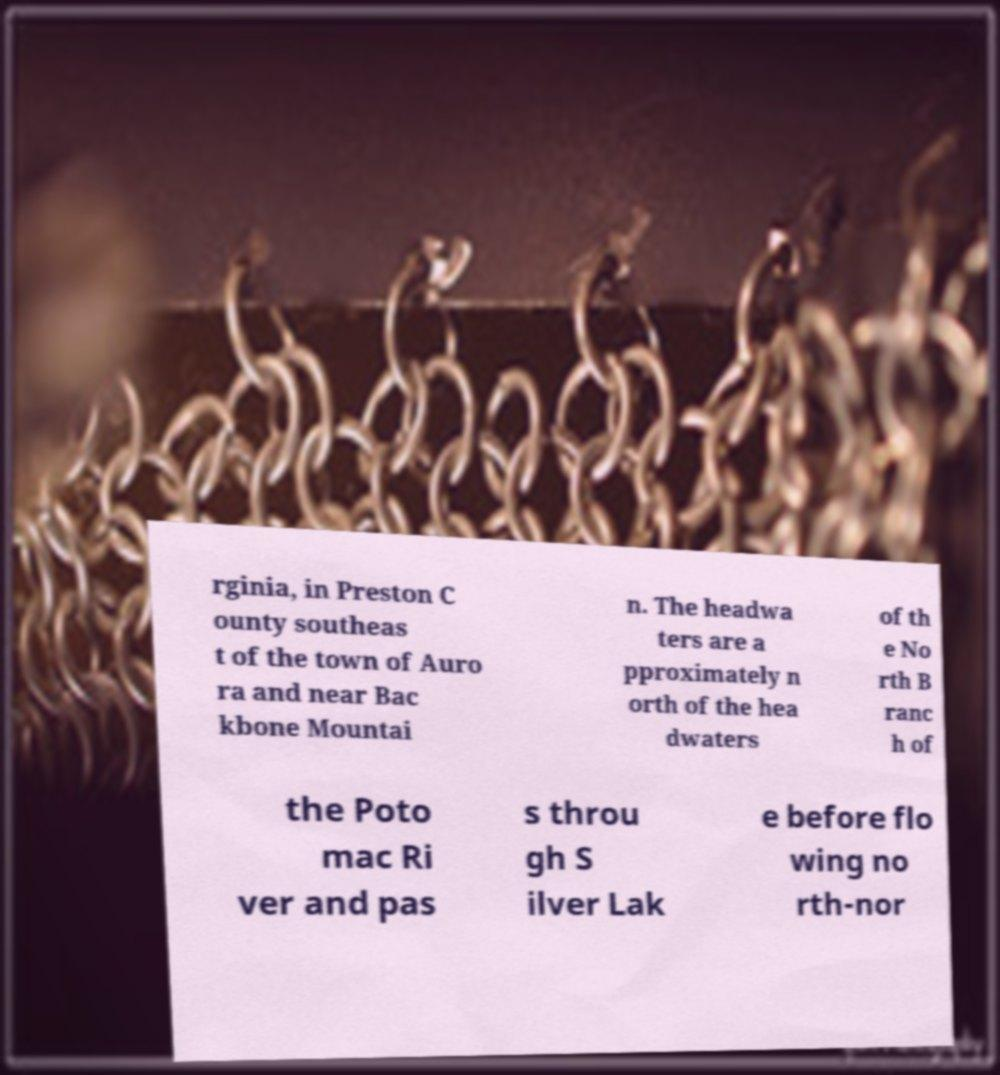Can you accurately transcribe the text from the provided image for me? rginia, in Preston C ounty southeas t of the town of Auro ra and near Bac kbone Mountai n. The headwa ters are a pproximately n orth of the hea dwaters of th e No rth B ranc h of the Poto mac Ri ver and pas s throu gh S ilver Lak e before flo wing no rth-nor 